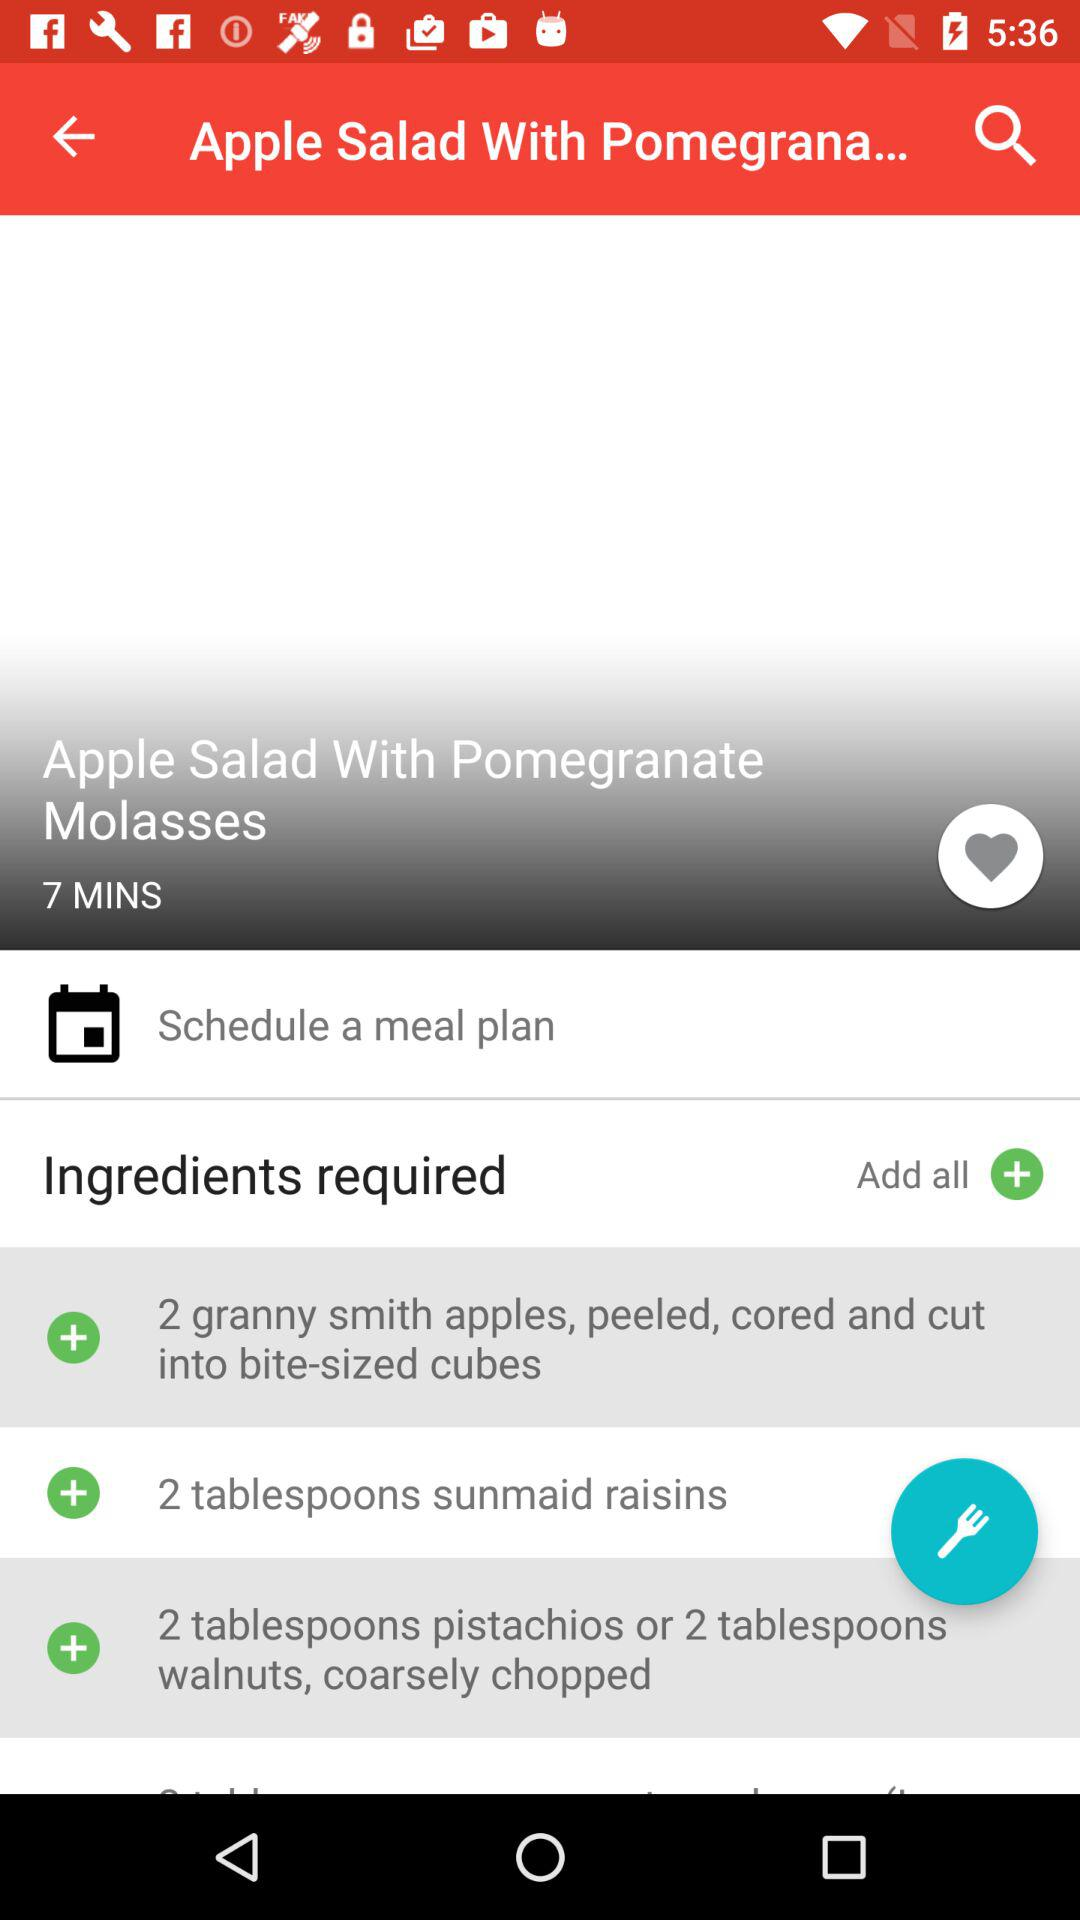How many ingredients in total are needed to make the apple salad?
When the provided information is insufficient, respond with <no answer>. <no answer> 